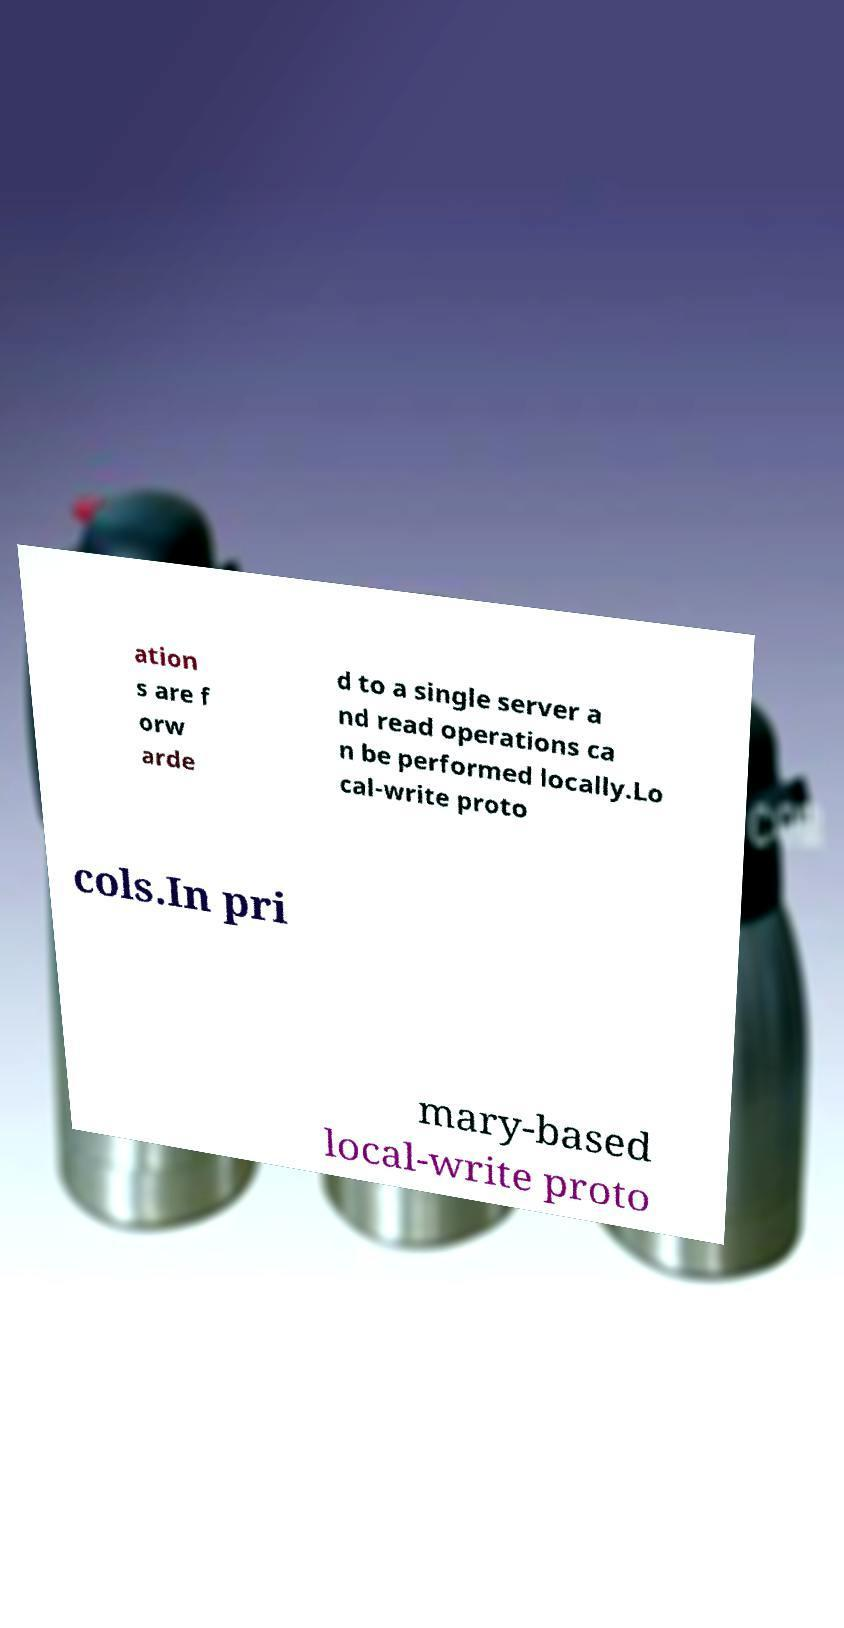I need the written content from this picture converted into text. Can you do that? ation s are f orw arde d to a single server a nd read operations ca n be performed locally.Lo cal-write proto cols.In pri mary-based local-write proto 